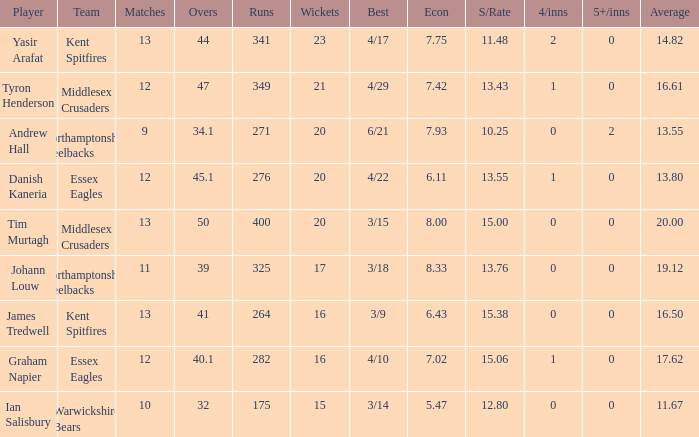What is the highest number of wickets taken for the best record of 4/22? 20.0. 